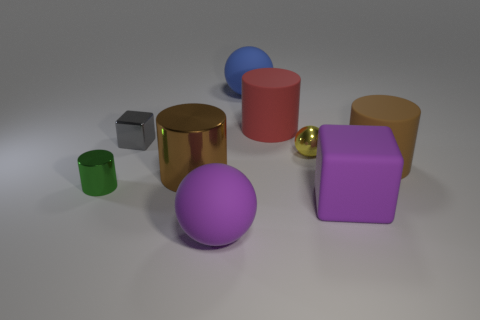Does the size of the objects affect how they are perceived in terms of color intensity or brightness? Yes, the perception of color intensity and brightness can be affected by the size of the object, as well as the lighting and surface texture. Larger surfaces may reflect more light, causing the color to appear more intense or brighter, while smaller objects might seem less vibrant. 